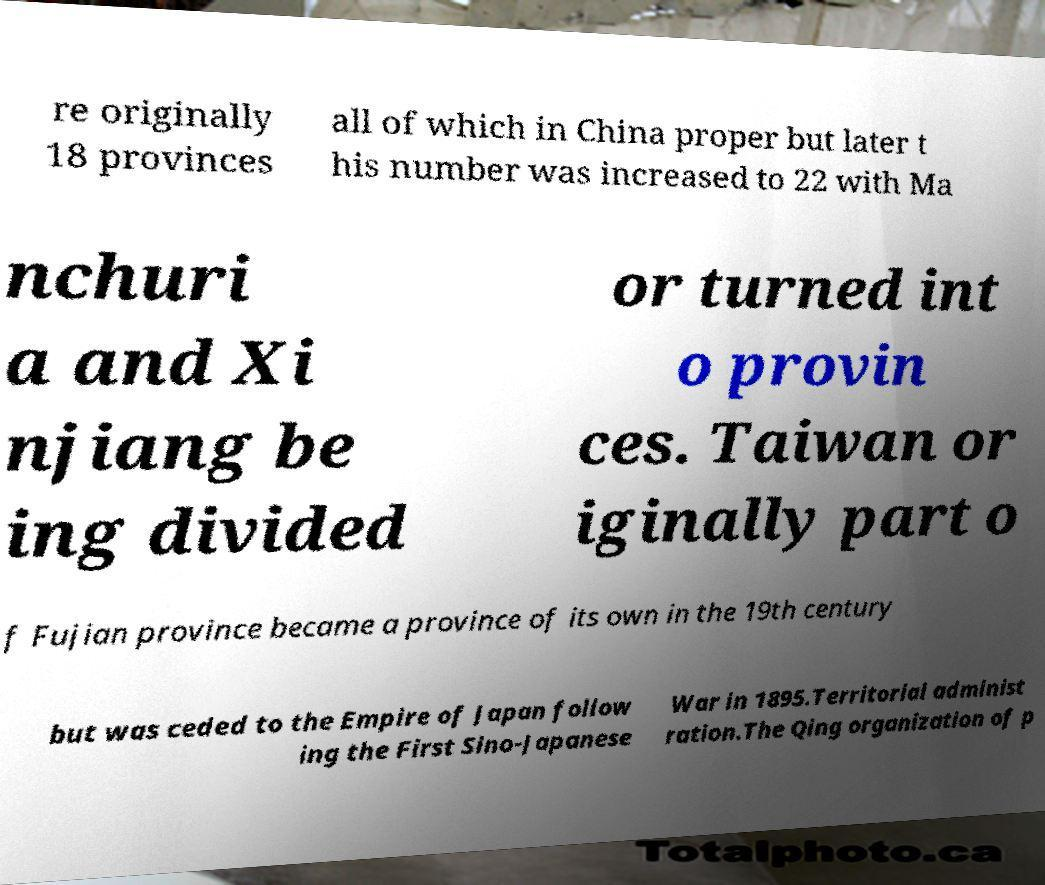Could you assist in decoding the text presented in this image and type it out clearly? re originally 18 provinces all of which in China proper but later t his number was increased to 22 with Ma nchuri a and Xi njiang be ing divided or turned int o provin ces. Taiwan or iginally part o f Fujian province became a province of its own in the 19th century but was ceded to the Empire of Japan follow ing the First Sino-Japanese War in 1895.Territorial administ ration.The Qing organization of p 